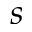Convert formula to latex. <formula><loc_0><loc_0><loc_500><loc_500>s</formula> 